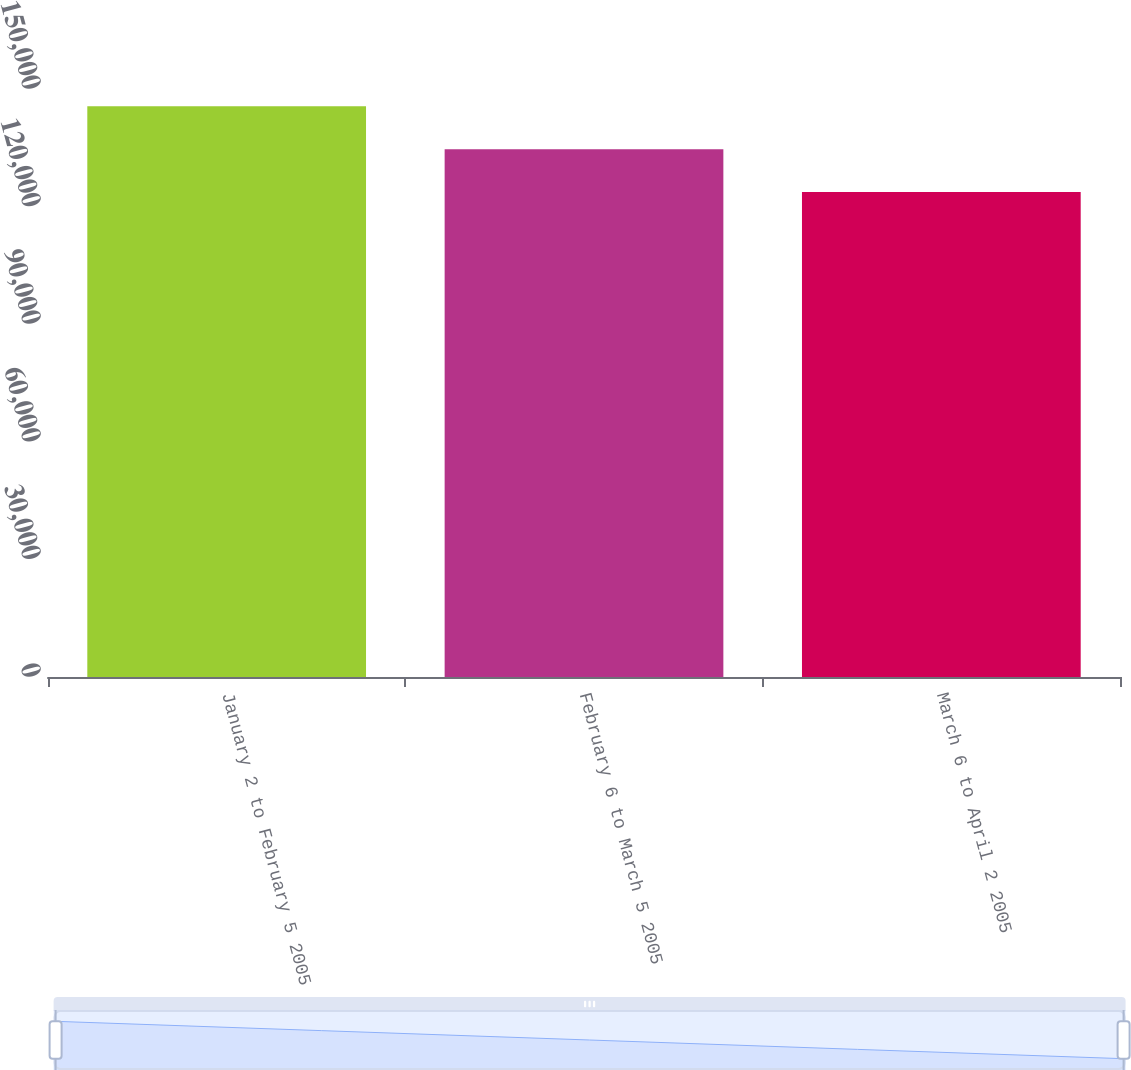Convert chart. <chart><loc_0><loc_0><loc_500><loc_500><bar_chart><fcel>January 2 to February 5 2005<fcel>February 6 to March 5 2005<fcel>March 6 to April 2 2005<nl><fcel>145583<fcel>134659<fcel>123747<nl></chart> 